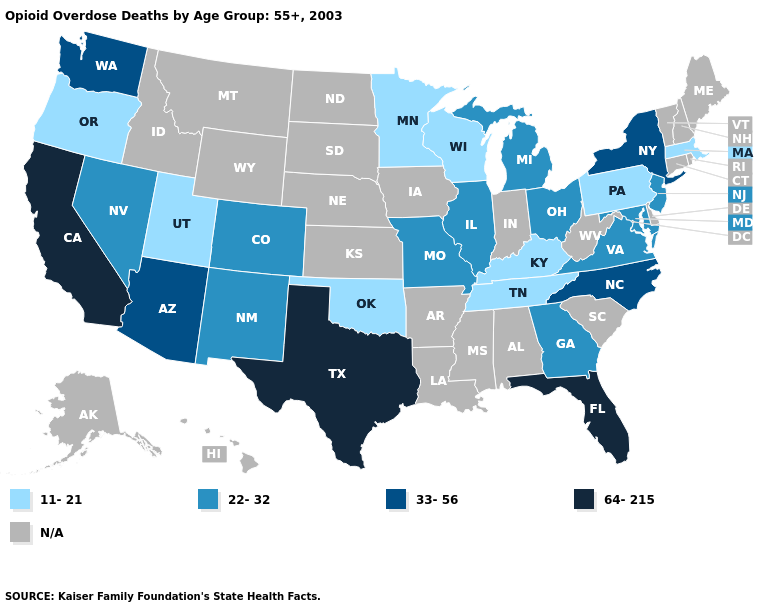What is the highest value in states that border Texas?
Keep it brief. 22-32. How many symbols are there in the legend?
Quick response, please. 5. Does Wisconsin have the lowest value in the USA?
Concise answer only. Yes. What is the lowest value in states that border Delaware?
Quick response, please. 11-21. Name the states that have a value in the range 33-56?
Quick response, please. Arizona, New York, North Carolina, Washington. Name the states that have a value in the range 33-56?
Concise answer only. Arizona, New York, North Carolina, Washington. What is the value of Kansas?
Give a very brief answer. N/A. Does Kentucky have the highest value in the USA?
Keep it brief. No. How many symbols are there in the legend?
Answer briefly. 5. Which states have the lowest value in the USA?
Keep it brief. Kentucky, Massachusetts, Minnesota, Oklahoma, Oregon, Pennsylvania, Tennessee, Utah, Wisconsin. What is the value of Washington?
Short answer required. 33-56. Among the states that border Michigan , does Ohio have the lowest value?
Quick response, please. No. What is the value of Arkansas?
Concise answer only. N/A. Does Ohio have the lowest value in the MidWest?
Write a very short answer. No. 